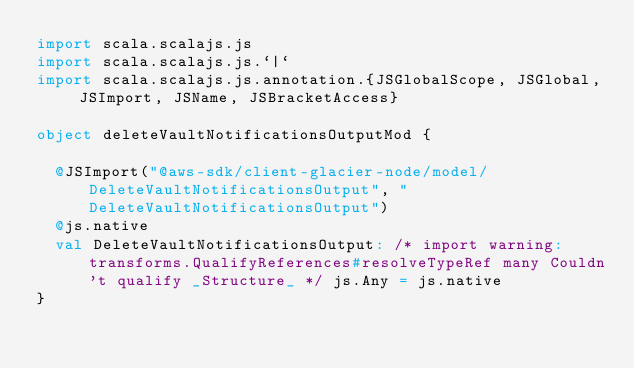<code> <loc_0><loc_0><loc_500><loc_500><_Scala_>import scala.scalajs.js
import scala.scalajs.js.`|`
import scala.scalajs.js.annotation.{JSGlobalScope, JSGlobal, JSImport, JSName, JSBracketAccess}

object deleteVaultNotificationsOutputMod {
  
  @JSImport("@aws-sdk/client-glacier-node/model/DeleteVaultNotificationsOutput", "DeleteVaultNotificationsOutput")
  @js.native
  val DeleteVaultNotificationsOutput: /* import warning: transforms.QualifyReferences#resolveTypeRef many Couldn't qualify _Structure_ */ js.Any = js.native
}
</code> 